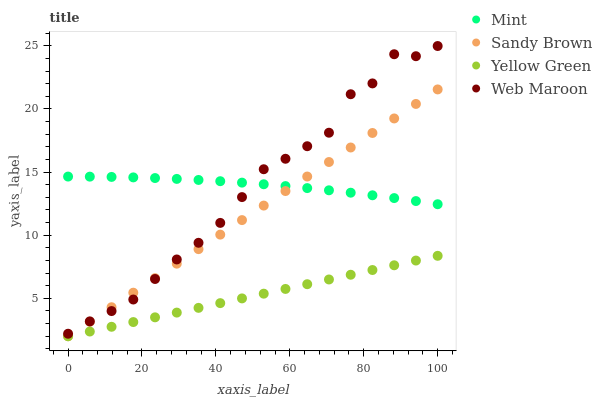Does Yellow Green have the minimum area under the curve?
Answer yes or no. Yes. Does Mint have the maximum area under the curve?
Answer yes or no. Yes. Does Mint have the minimum area under the curve?
Answer yes or no. No. Does Yellow Green have the maximum area under the curve?
Answer yes or no. No. Is Yellow Green the smoothest?
Answer yes or no. Yes. Is Web Maroon the roughest?
Answer yes or no. Yes. Is Mint the smoothest?
Answer yes or no. No. Is Mint the roughest?
Answer yes or no. No. Does Sandy Brown have the lowest value?
Answer yes or no. Yes. Does Mint have the lowest value?
Answer yes or no. No. Does Web Maroon have the highest value?
Answer yes or no. Yes. Does Mint have the highest value?
Answer yes or no. No. Is Yellow Green less than Web Maroon?
Answer yes or no. Yes. Is Mint greater than Yellow Green?
Answer yes or no. Yes. Does Sandy Brown intersect Yellow Green?
Answer yes or no. Yes. Is Sandy Brown less than Yellow Green?
Answer yes or no. No. Is Sandy Brown greater than Yellow Green?
Answer yes or no. No. Does Yellow Green intersect Web Maroon?
Answer yes or no. No. 